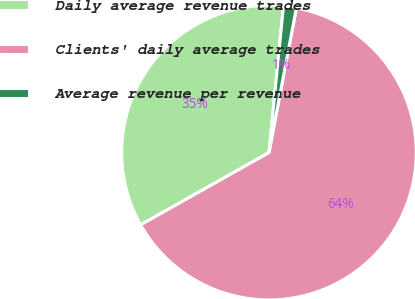Convert chart. <chart><loc_0><loc_0><loc_500><loc_500><pie_chart><fcel>Daily average revenue trades<fcel>Clients' daily average trades<fcel>Average revenue per revenue<nl><fcel>34.73%<fcel>63.86%<fcel>1.41%<nl></chart> 